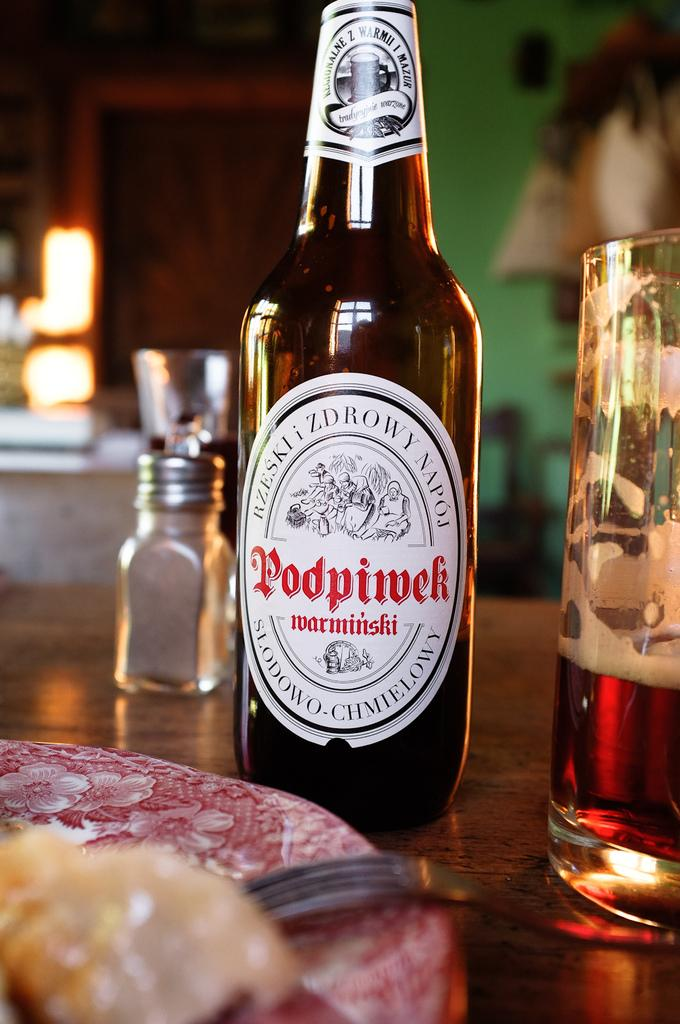<image>
Relay a brief, clear account of the picture shown. A glass of beer has been poured from a Podpimek bottle. 